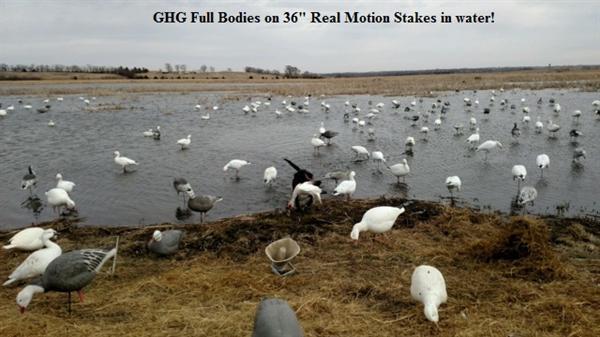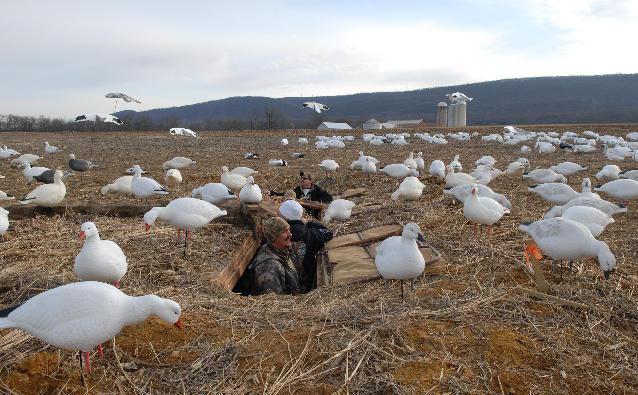The first image is the image on the left, the second image is the image on the right. For the images shown, is this caption "Has atleast one picture with 6 or less ducks." true? Answer yes or no. No. 